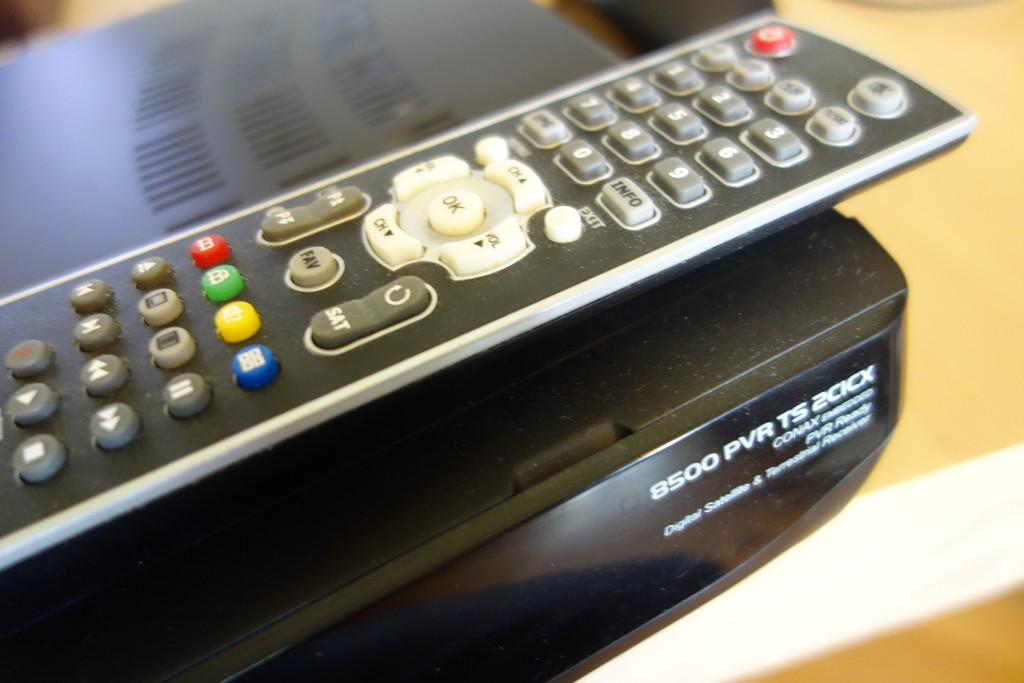<image>
Relay a brief, clear account of the picture shown. A television remote control with a pvr ts 200k device. 